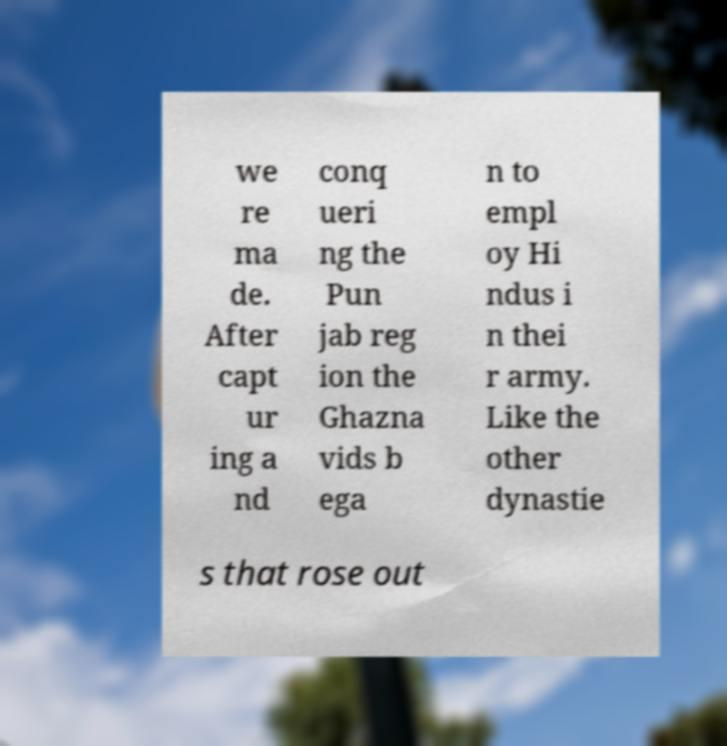Please read and relay the text visible in this image. What does it say? we re ma de. After capt ur ing a nd conq ueri ng the Pun jab reg ion the Ghazna vids b ega n to empl oy Hi ndus i n thei r army. Like the other dynastie s that rose out 